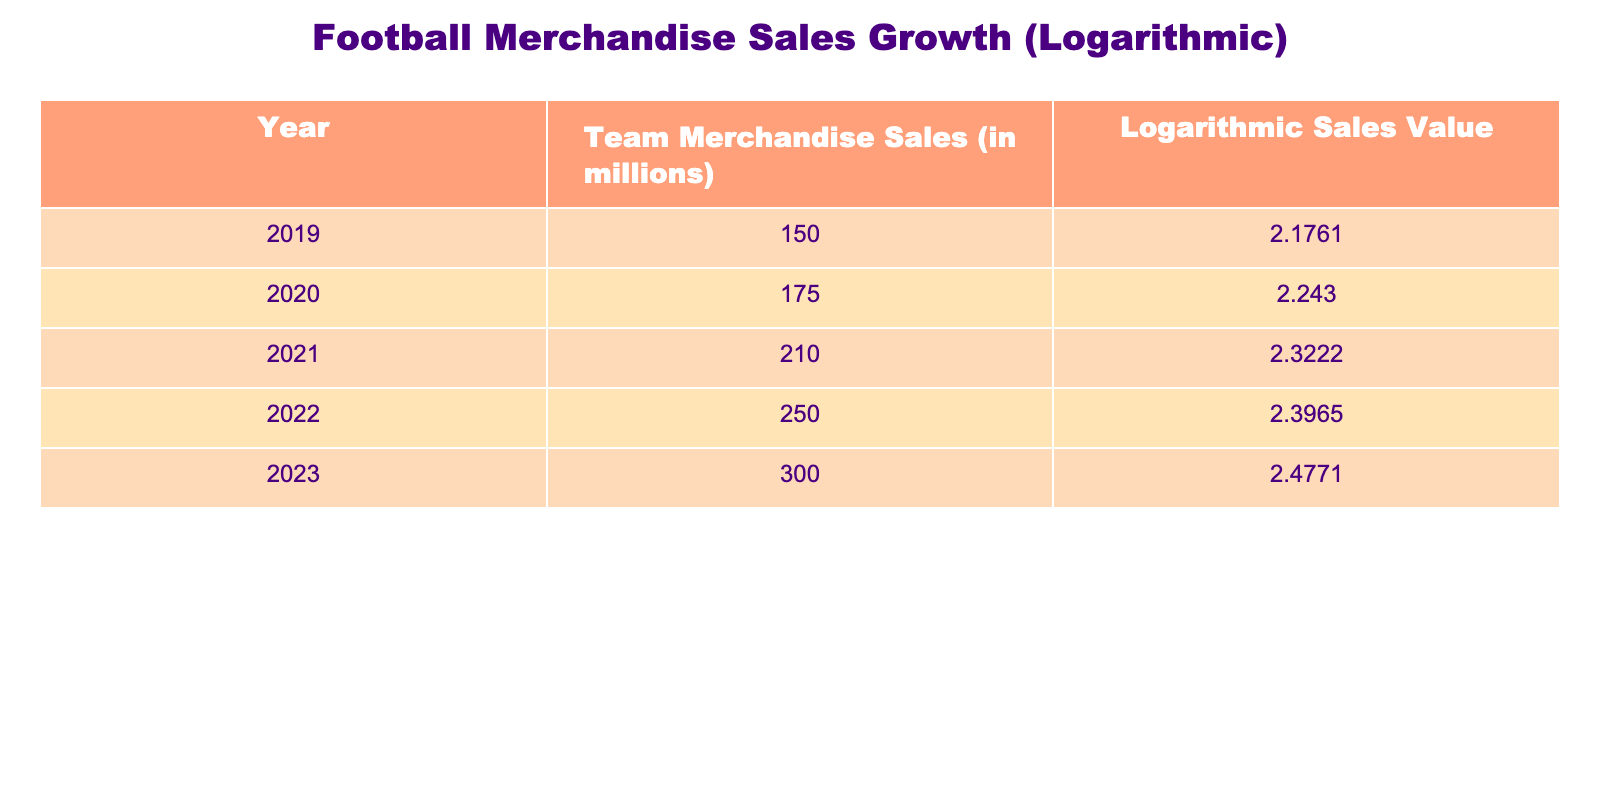What was the merchandise sales for 2022? The table indicates that the merchandise sales for 2022 are recorded at 250 million.
Answer: 250 million What is the logarithmic sales value for 2020? According to the table, for the year 2020, the logarithmic sales value is 2.2430.
Answer: 2.2430 Which year saw the highest merchandise sales growth compared to the previous year? By comparing the sales data year over year, the greatest increase is from 2022 to 2023, where sales went from 250 million to 300 million, a difference of 50 million.
Answer: 2023 What is the average merchandise sales over the five years? To calculate the average, sum all sales values from 2019 to 2023 (150 + 175 + 210 + 250 + 300 = 1085), and then divide by the number of years (5). The average is 1085 / 5 = 217 million.
Answer: 217 million Is the merchandise sales in 2021 greater than 200 million? The sales figure for 2021 is 210 million, which is indeed greater than 200 million. Thus, the statement is true.
Answer: Yes What was the percentage increase in merchandise sales from 2019 to 2023? The sales in 2019 were 150 million and in 2023 they are 300 million. The increase is 300 - 150 = 150 million. To find the percentage increase, divide the increase by the original amount (150 / 150 = 1) and multiply by 100, resulting in a 100% increase.
Answer: 100% Which year had the lowest logarithmic sales value? Looking at the logarithmic sales values, in 2019 the value is the lowest at 2.1761 compared to subsequent years.
Answer: 2019 What is the difference in logarithmic sales between 2021 and 2022? The logarithmic value for 2021 is 2.3222 and for 2022 is 2.3965. To find the difference, subtract 2.3222 from 2.3965, which equals 0.0743.
Answer: 0.0743 Does 2020 have a higher sales value than 2019? The sales for 2020 are recorded at 175 million, while for 2019 they are at 150 million. Therefore, 2020 does have a higher sales value than 2019.
Answer: Yes 